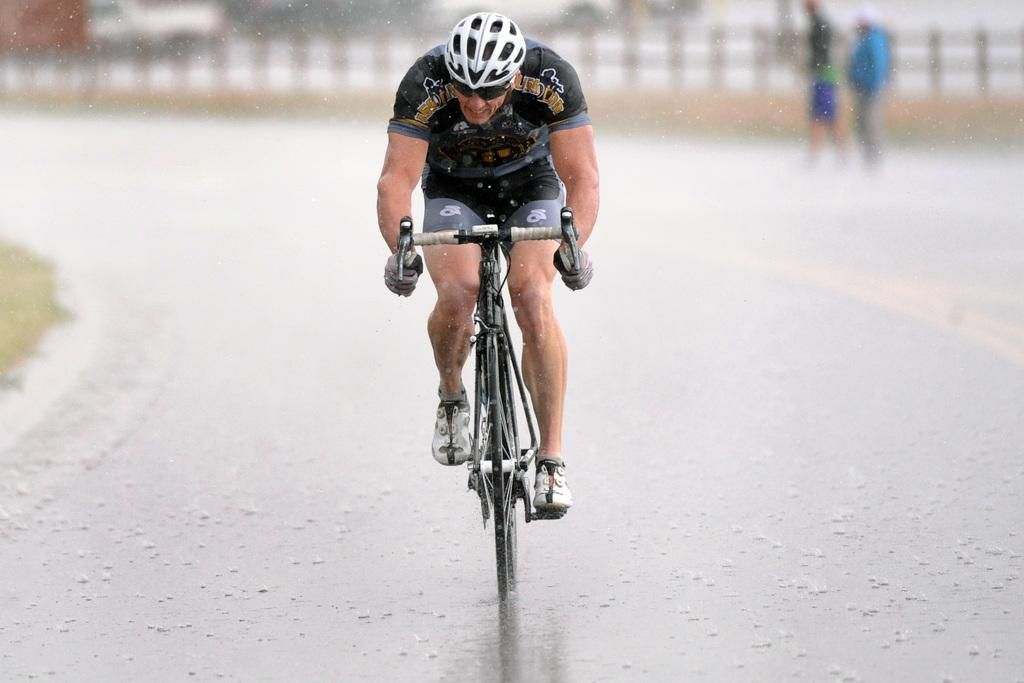Who is the main subject in the image? There is a man in the image. What is the man doing in the image? The man is riding a cycle. What safety gear is the man wearing? The man is wearing a white helmet. What can be seen at the bottom of the image? There is a road at the bottom of the image. What is the weather condition in the image? Snow is visible on the road, indicating a snowy condition. How would you describe the background of the image? The background of the image is blurred. What type of flowers can be seen growing on the page in the image? There is no page or flowers present in the image; it features a man riding a cycle on a snowy road. 